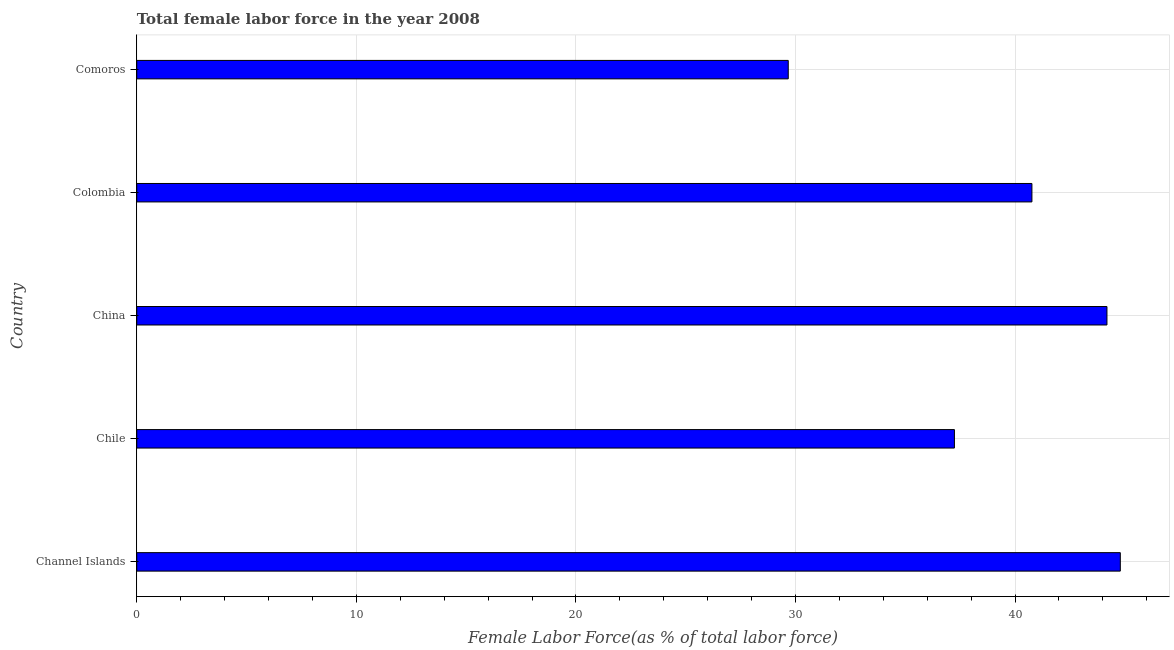Does the graph contain any zero values?
Ensure brevity in your answer.  No. What is the title of the graph?
Ensure brevity in your answer.  Total female labor force in the year 2008. What is the label or title of the X-axis?
Make the answer very short. Female Labor Force(as % of total labor force). What is the label or title of the Y-axis?
Offer a terse response. Country. What is the total female labor force in Colombia?
Offer a very short reply. 40.77. Across all countries, what is the maximum total female labor force?
Offer a very short reply. 44.79. Across all countries, what is the minimum total female labor force?
Offer a very short reply. 29.67. In which country was the total female labor force maximum?
Ensure brevity in your answer.  Channel Islands. In which country was the total female labor force minimum?
Your answer should be very brief. Comoros. What is the sum of the total female labor force?
Provide a short and direct response. 196.66. What is the difference between the total female labor force in China and Colombia?
Make the answer very short. 3.42. What is the average total female labor force per country?
Your answer should be compact. 39.33. What is the median total female labor force?
Keep it short and to the point. 40.77. In how many countries, is the total female labor force greater than 32 %?
Your response must be concise. 4. What is the ratio of the total female labor force in Chile to that in Colombia?
Your answer should be compact. 0.91. Is the difference between the total female labor force in Colombia and Comoros greater than the difference between any two countries?
Keep it short and to the point. No. What is the difference between the highest and the second highest total female labor force?
Offer a terse response. 0.61. Is the sum of the total female labor force in Channel Islands and China greater than the maximum total female labor force across all countries?
Provide a succinct answer. Yes. What is the difference between the highest and the lowest total female labor force?
Ensure brevity in your answer.  15.12. In how many countries, is the total female labor force greater than the average total female labor force taken over all countries?
Your answer should be compact. 3. Are the values on the major ticks of X-axis written in scientific E-notation?
Offer a very short reply. No. What is the Female Labor Force(as % of total labor force) of Channel Islands?
Give a very brief answer. 44.79. What is the Female Labor Force(as % of total labor force) of Chile?
Make the answer very short. 37.24. What is the Female Labor Force(as % of total labor force) in China?
Your answer should be compact. 44.19. What is the Female Labor Force(as % of total labor force) of Colombia?
Your response must be concise. 40.77. What is the Female Labor Force(as % of total labor force) of Comoros?
Offer a very short reply. 29.67. What is the difference between the Female Labor Force(as % of total labor force) in Channel Islands and Chile?
Offer a terse response. 7.56. What is the difference between the Female Labor Force(as % of total labor force) in Channel Islands and China?
Make the answer very short. 0.61. What is the difference between the Female Labor Force(as % of total labor force) in Channel Islands and Colombia?
Ensure brevity in your answer.  4.03. What is the difference between the Female Labor Force(as % of total labor force) in Channel Islands and Comoros?
Provide a succinct answer. 15.12. What is the difference between the Female Labor Force(as % of total labor force) in Chile and China?
Offer a very short reply. -6.95. What is the difference between the Female Labor Force(as % of total labor force) in Chile and Colombia?
Your answer should be compact. -3.53. What is the difference between the Female Labor Force(as % of total labor force) in Chile and Comoros?
Keep it short and to the point. 7.57. What is the difference between the Female Labor Force(as % of total labor force) in China and Colombia?
Your answer should be compact. 3.42. What is the difference between the Female Labor Force(as % of total labor force) in China and Comoros?
Provide a succinct answer. 14.52. What is the difference between the Female Labor Force(as % of total labor force) in Colombia and Comoros?
Ensure brevity in your answer.  11.1. What is the ratio of the Female Labor Force(as % of total labor force) in Channel Islands to that in Chile?
Your answer should be compact. 1.2. What is the ratio of the Female Labor Force(as % of total labor force) in Channel Islands to that in Colombia?
Your answer should be compact. 1.1. What is the ratio of the Female Labor Force(as % of total labor force) in Channel Islands to that in Comoros?
Provide a short and direct response. 1.51. What is the ratio of the Female Labor Force(as % of total labor force) in Chile to that in China?
Offer a very short reply. 0.84. What is the ratio of the Female Labor Force(as % of total labor force) in Chile to that in Comoros?
Your response must be concise. 1.25. What is the ratio of the Female Labor Force(as % of total labor force) in China to that in Colombia?
Your answer should be very brief. 1.08. What is the ratio of the Female Labor Force(as % of total labor force) in China to that in Comoros?
Provide a short and direct response. 1.49. What is the ratio of the Female Labor Force(as % of total labor force) in Colombia to that in Comoros?
Your response must be concise. 1.37. 